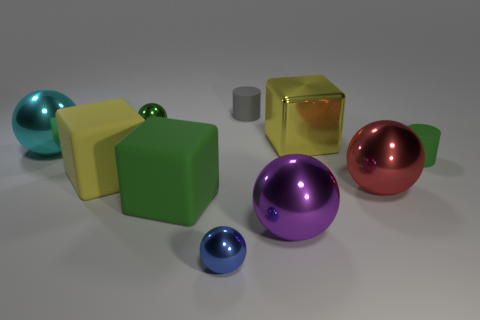There is a gray cylinder; how many small matte cylinders are right of it?
Provide a succinct answer. 1. Are there an equal number of green metallic spheres behind the gray cylinder and green cubes that are to the right of the green sphere?
Offer a very short reply. No. What size is the yellow shiny thing that is the same shape as the large green rubber thing?
Give a very brief answer. Large. There is a tiny rubber object that is to the left of the purple sphere; what is its shape?
Provide a succinct answer. Cylinder. Does the yellow thing that is on the left side of the tiny gray rubber cylinder have the same material as the small sphere that is left of the blue sphere?
Your answer should be compact. No. The small green metal object is what shape?
Your answer should be compact. Sphere. Are there the same number of blocks behind the big green block and cyan cylinders?
Provide a succinct answer. No. What is the size of the rubber cube that is the same color as the shiny cube?
Give a very brief answer. Large. Is there a yellow object that has the same material as the red thing?
Give a very brief answer. Yes. Does the tiny thing that is to the left of the tiny blue object have the same shape as the tiny shiny thing in front of the big red thing?
Your answer should be very brief. Yes. 